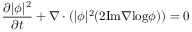Convert formula to latex. <formula><loc_0><loc_0><loc_500><loc_500>\frac { \partial | \phi | ^ { 2 } } { \partial t } + \nabla \cdot ( | \phi | ^ { 2 } ( 2 I m \nabla \log \phi ) ) = 0</formula> 